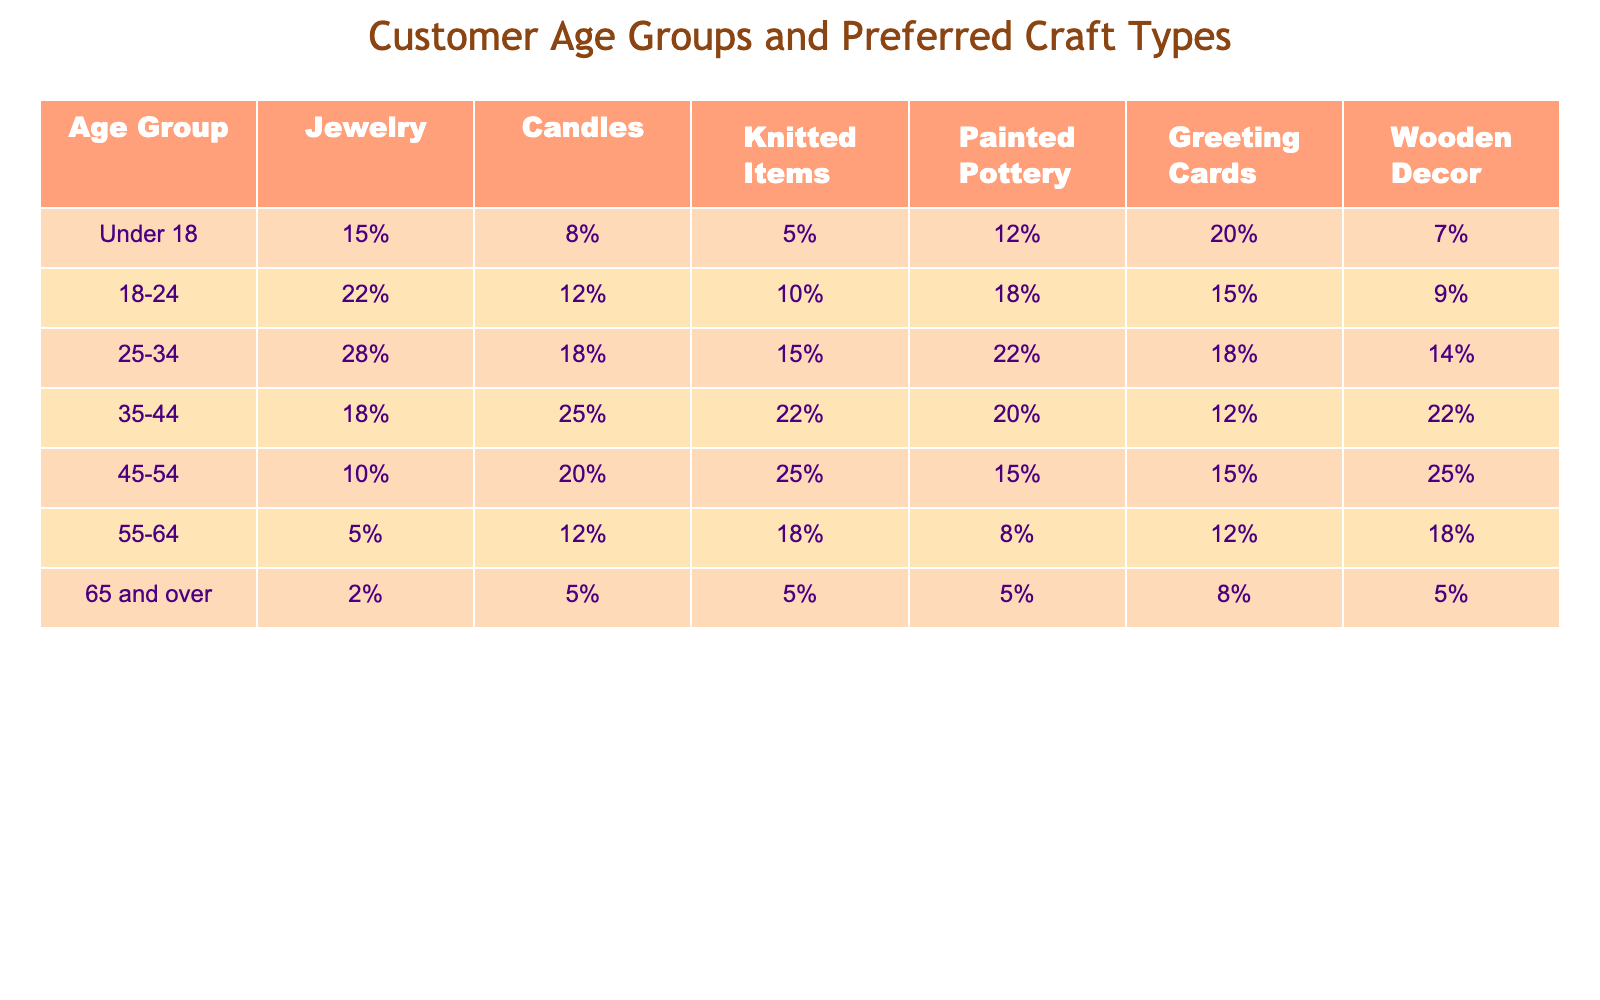What age group prefers painted pottery the most? Looking at the painted pottery column, the highest percentage is 22% in the age group 25-34.
Answer: 25-34 Which age group has the least preference for jewelry? The lowest percentage for jewelry is found in the age group 65 and over, with only 2%.
Answer: 65 and over What is the difference in percentage preference for candles between the age groups 35-44 and 25-34? The percentage for candles in 35-44 is 25%, and in 25-34 it is 18%. The difference is 25% - 18% = 7%.
Answer: 7% Is the preference for wooden decor higher in the 45-54 age group or the 55-64 age group? In the 45-54 age group, the preference for wooden decor is 25%, while in the 55-64 age group it is 18%. Therefore, the 45-54 age group has a higher preference.
Answer: Yes What is the total percentage preference for greeting cards among the 18-24 and 25-34 age groups? For the 18-24 age group, the preference is 15%, and for the 25-34 age group, it is 18%. The total is 15% + 18% = 33%.
Answer: 33% Which age group has the most balanced preferences across all craft types? The age group 35-44 shows relatively balanced and comparable percentages across all types, especially high rates in several crafts (25% for candles and 22% for knitted items).
Answer: 35-44 How does the preference for candles shift from the under 18 to the 45-54 age group? The percentage drops from 8% in under 18 to 20% in 45-54, indicating an increasing preference.
Answer: It increases What percentage of the 65 and over group prefers knitted items? The percentage preference for knitted items in the 65 and over group is 5%.
Answer: 5% 